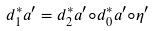Convert formula to latex. <formula><loc_0><loc_0><loc_500><loc_500>d _ { 1 } ^ { * } a ^ { \prime } = d _ { 2 } ^ { * } a ^ { \prime } \circ d _ { 0 } ^ { * } a ^ { \prime } \circ \eta ^ { \prime }</formula> 